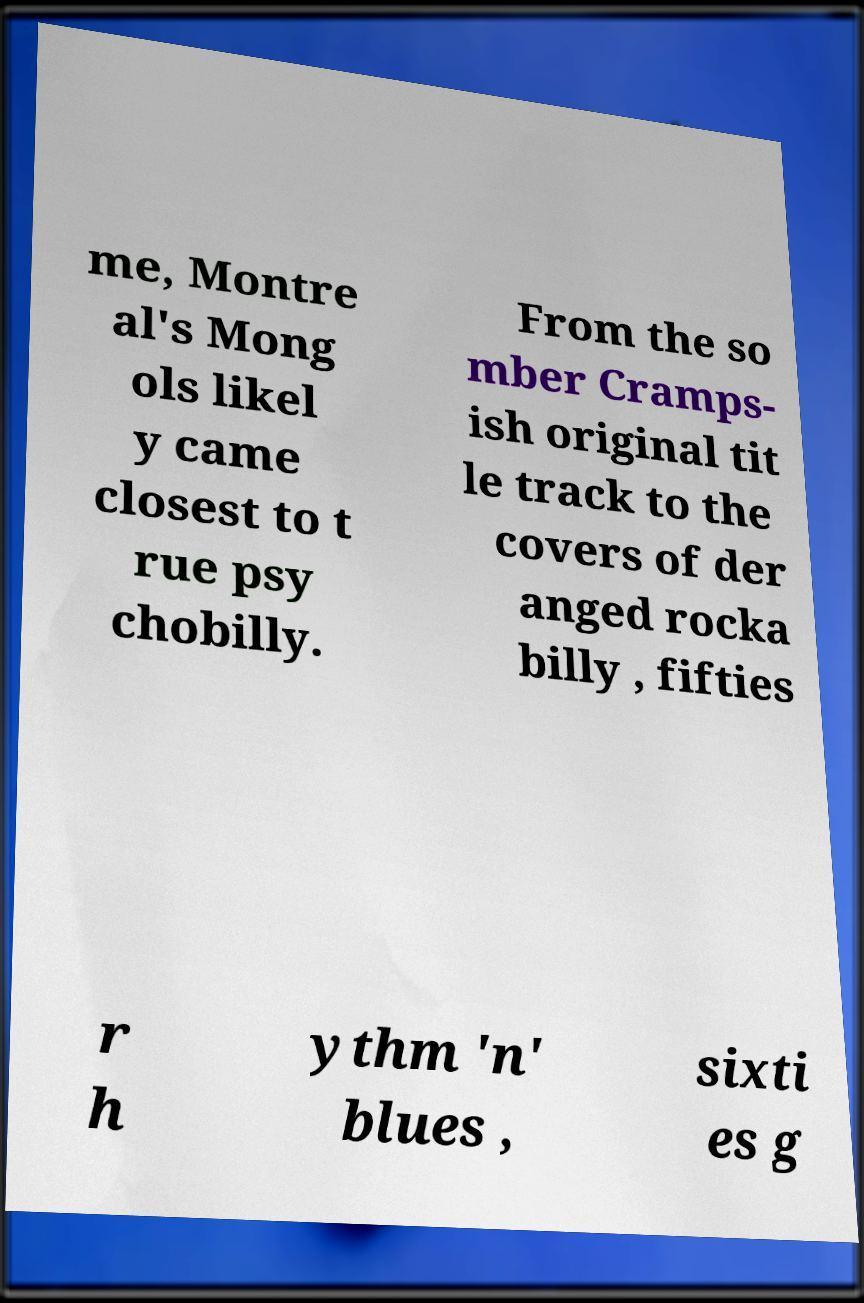Could you extract and type out the text from this image? me, Montre al's Mong ols likel y came closest to t rue psy chobilly. From the so mber Cramps- ish original tit le track to the covers of der anged rocka billy , fifties r h ythm 'n' blues , sixti es g 